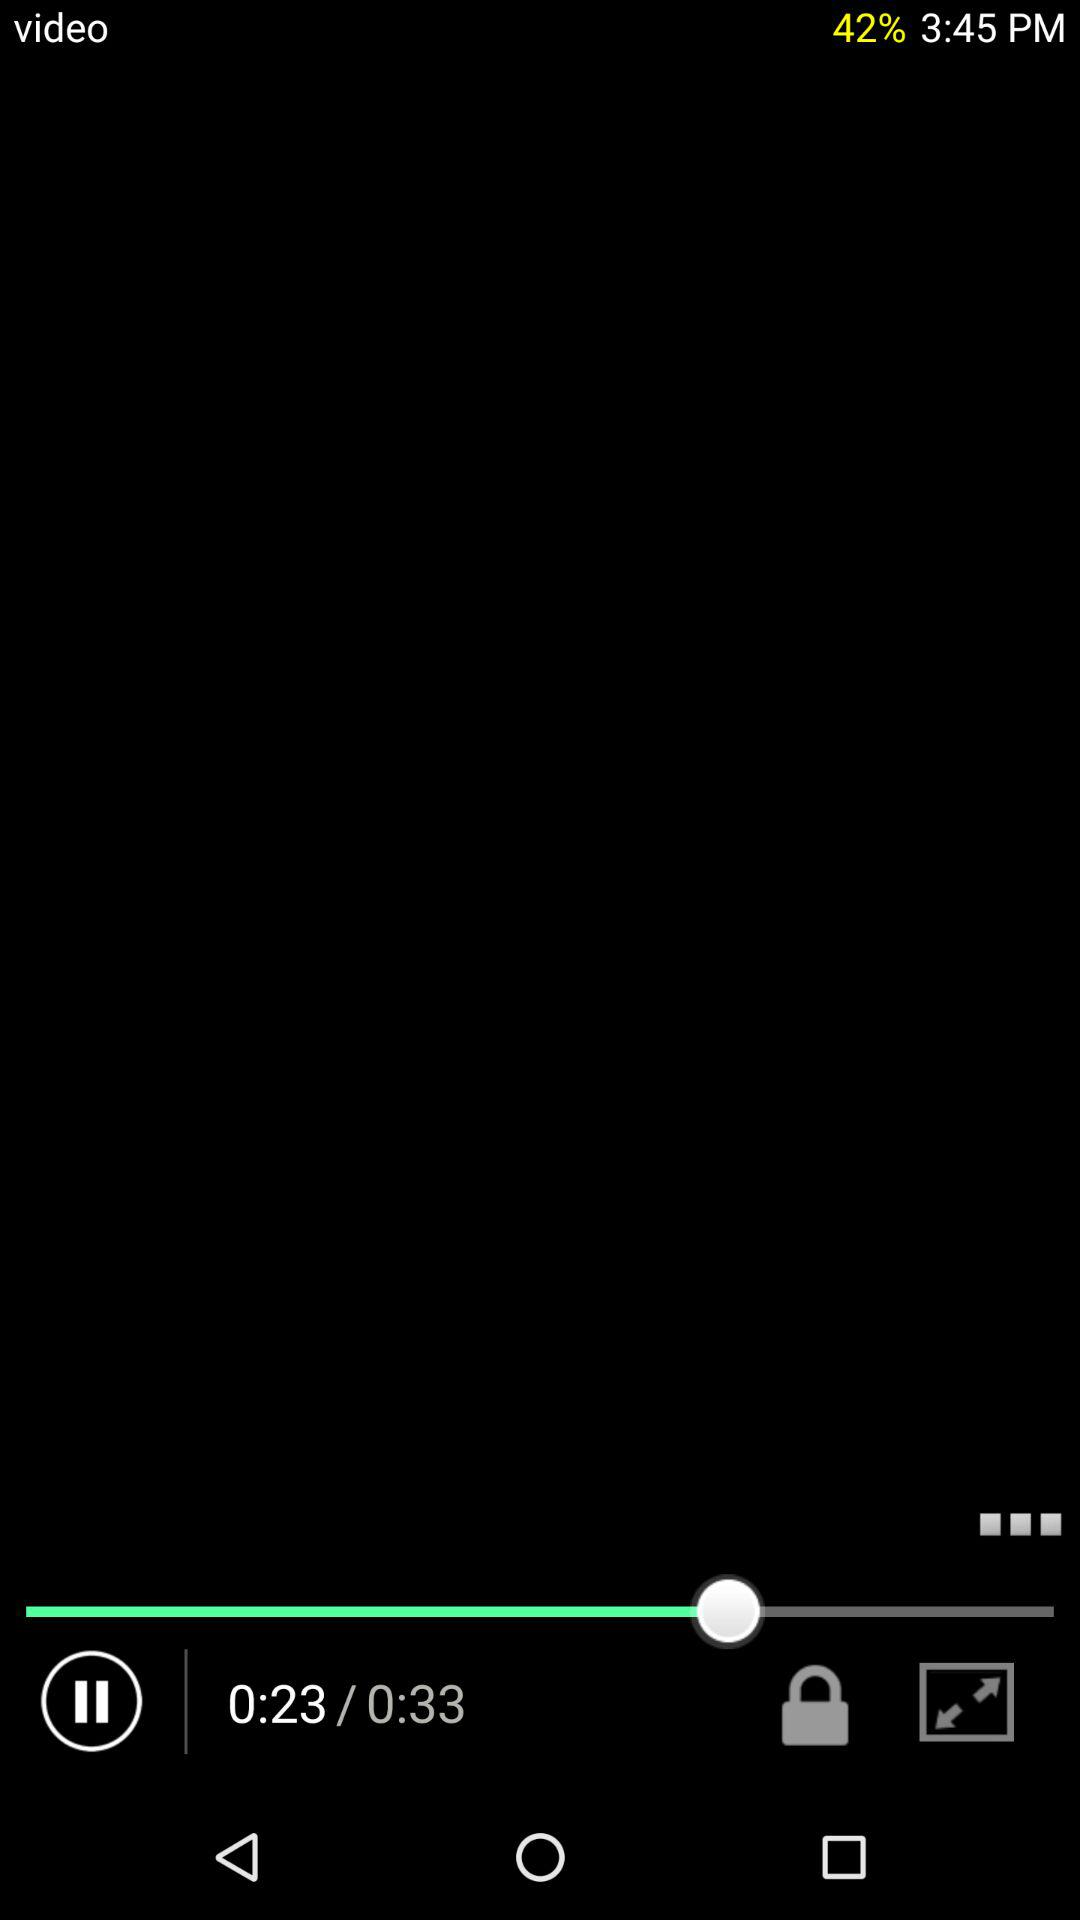How long is the video? The video is 33 seconds long. 